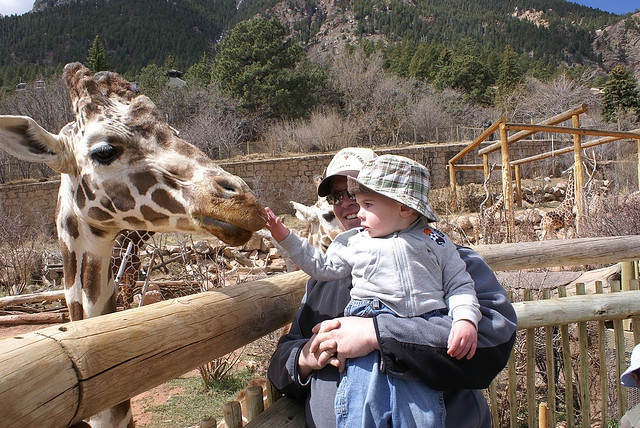Describe the objects in this image and their specific colors. I can see giraffe in white, gray, darkgray, and maroon tones, people in white, darkgray, and gray tones, people in white, black, gray, and darkgray tones, giraffe in white, black, maroon, and gray tones, and giraffe in white, lightgray, gray, tan, and darkgray tones in this image. 